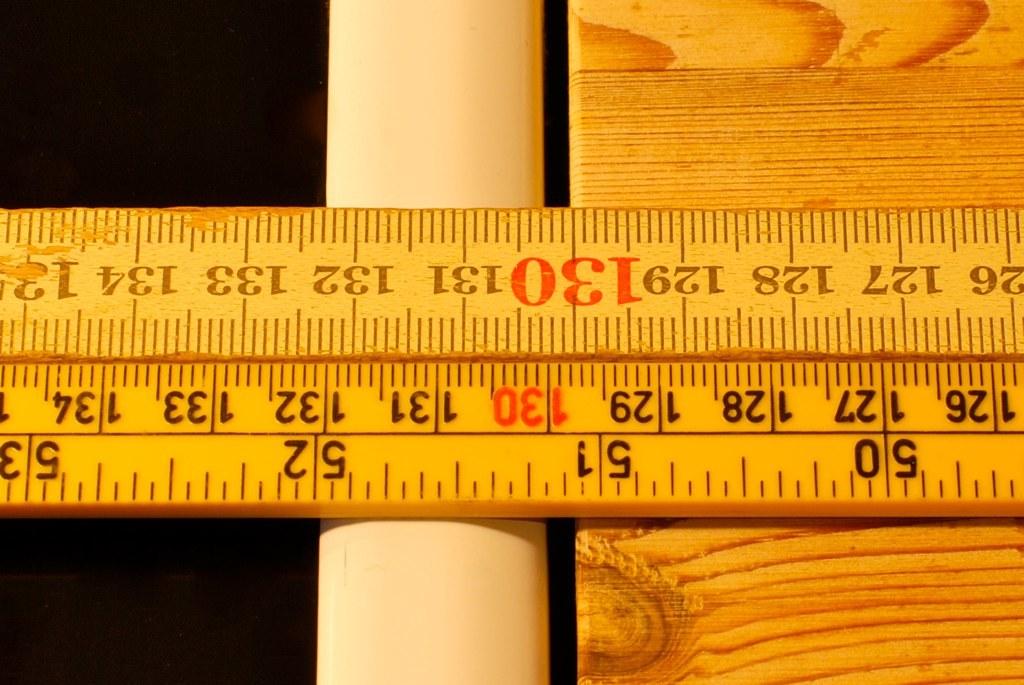What is the number highlighted in red on the ruler?
Ensure brevity in your answer.  130. 